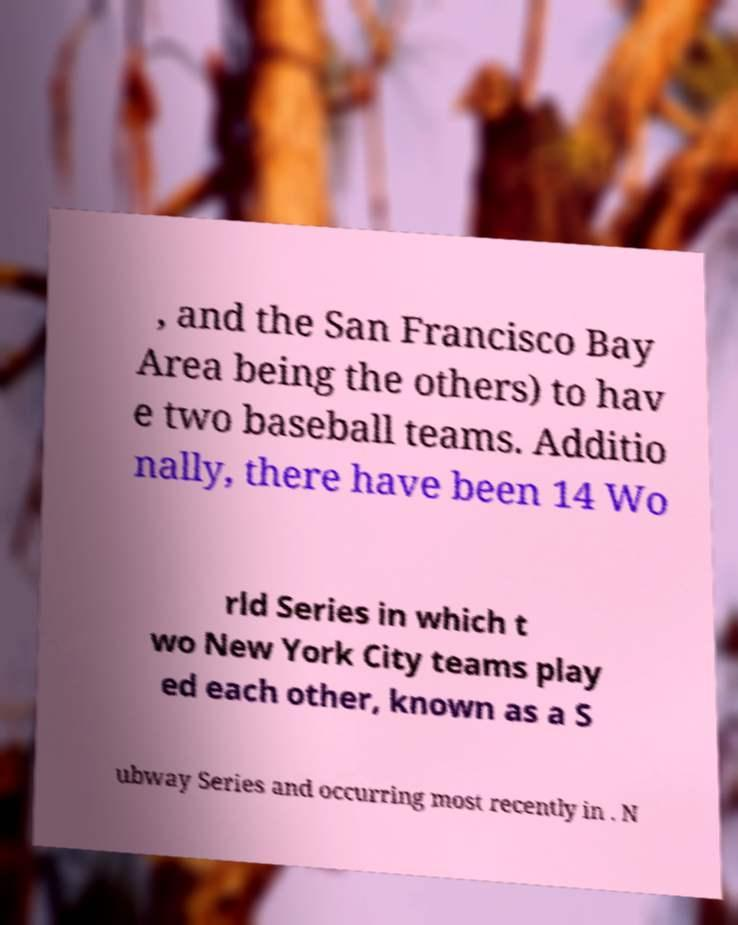Could you assist in decoding the text presented in this image and type it out clearly? , and the San Francisco Bay Area being the others) to hav e two baseball teams. Additio nally, there have been 14 Wo rld Series in which t wo New York City teams play ed each other, known as a S ubway Series and occurring most recently in . N 